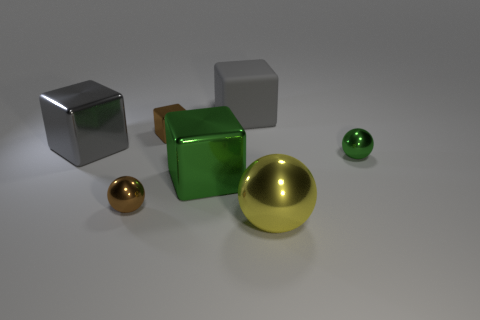What size is the cube that is to the left of the gray rubber thing and to the right of the brown metallic cube?
Offer a terse response. Large. Is there any other thing that has the same color as the large rubber thing?
Your answer should be compact. Yes. How big is the green metal cube in front of the small object that is on the right side of the large metallic sphere?
Your answer should be very brief. Large. There is a large thing that is left of the large gray rubber thing and on the right side of the brown ball; what color is it?
Your response must be concise. Green. What number of other things are there of the same size as the yellow shiny ball?
Make the answer very short. 3. Do the gray metal cube and the brown thing behind the small green thing have the same size?
Keep it short and to the point. No. There is a shiny sphere that is the same size as the gray metal block; what is its color?
Offer a very short reply. Yellow. The brown shiny block has what size?
Your answer should be very brief. Small. Is the material of the brown sphere in front of the tiny block the same as the yellow thing?
Your answer should be very brief. Yes. Is the yellow metallic object the same shape as the small green object?
Keep it short and to the point. Yes. 